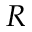Convert formula to latex. <formula><loc_0><loc_0><loc_500><loc_500>R</formula> 